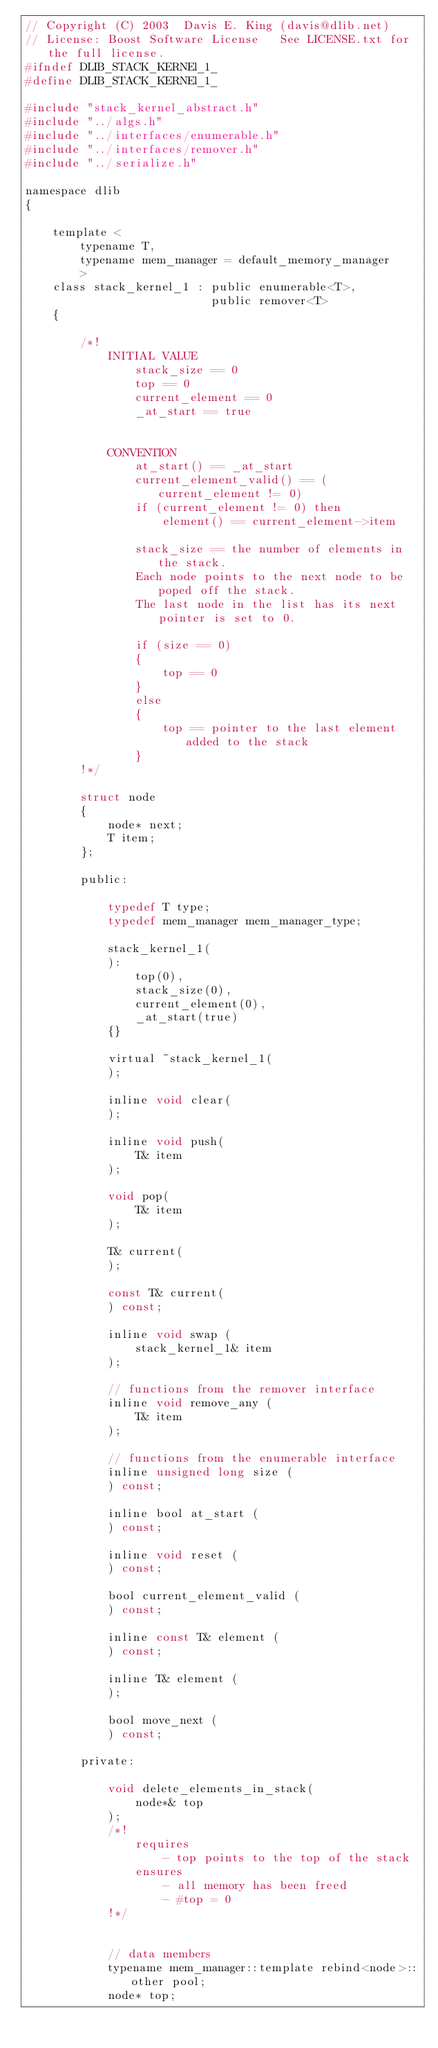Convert code to text. <code><loc_0><loc_0><loc_500><loc_500><_C_>// Copyright (C) 2003  Davis E. King (davis@dlib.net)
// License: Boost Software License   See LICENSE.txt for the full license.
#ifndef DLIB_STACK_KERNEl_1_
#define DLIB_STACK_KERNEl_1_

#include "stack_kernel_abstract.h"
#include "../algs.h"
#include "../interfaces/enumerable.h"
#include "../interfaces/remover.h"
#include "../serialize.h"

namespace dlib
{

    template <
        typename T,
        typename mem_manager = default_memory_manager
        >
    class stack_kernel_1 : public enumerable<T>,
                           public remover<T>
    {

        /*!
            INITIAL VALUE
                stack_size == 0 
                top == 0
                current_element == 0
                _at_start == true


            CONVENTION
                at_start() == _at_start
                current_element_valid() == (current_element != 0)
                if (current_element != 0) then
                    element() == current_element->item

                stack_size == the number of elements in the stack. 
                Each node points to the next node to be poped off the stack.
                The last node in the list has its next pointer is set to 0.
                
                if (size == 0)
                {
                    top == 0
                }
                else
                {
                    top == pointer to the last element added to the stack
                }
        !*/
        
        struct node
        {
            node* next;
            T item;
        };
        
        public:

            typedef T type;
            typedef mem_manager mem_manager_type;

            stack_kernel_1(
            ):
                top(0),
                stack_size(0),
                current_element(0),
                _at_start(true)
            {}
    
            virtual ~stack_kernel_1(
            );

            inline void clear(
            );

            inline void push(
                T& item
            );

            void pop(
                T& item
            );

            T& current(
            );

            const T& current(
            ) const;

            inline void swap (
                stack_kernel_1& item
            );
        
            // functions from the remover interface
            inline void remove_any (
                T& item
            ); 

            // functions from the enumerable interface
            inline unsigned long size (
            ) const;

            inline bool at_start (
            ) const;

            inline void reset (
            ) const;

            bool current_element_valid (
            ) const;

            inline const T& element (
            ) const;

            inline T& element (
            );

            bool move_next (
            ) const;

        private:

            void delete_elements_in_stack(
                node*& top
            );
            /*!
                requires
                    - top points to the top of the stack
                ensures
                    - all memory has been freed 
                    - #top = 0
            !*/


            // data members
            typename mem_manager::template rebind<node>::other pool;
            node* top;</code> 